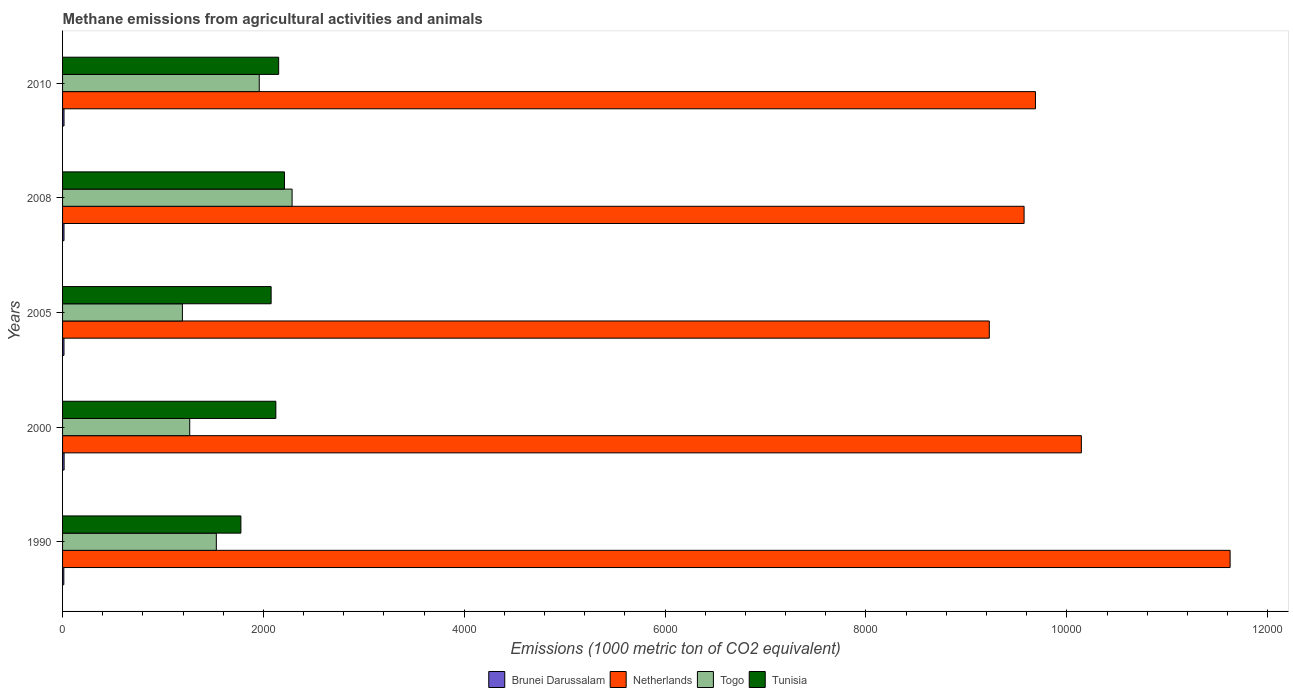Are the number of bars per tick equal to the number of legend labels?
Provide a succinct answer. Yes. Are the number of bars on each tick of the Y-axis equal?
Make the answer very short. Yes. How many bars are there on the 4th tick from the bottom?
Your answer should be compact. 4. In how many cases, is the number of bars for a given year not equal to the number of legend labels?
Provide a short and direct response. 0. Across all years, what is the maximum amount of methane emitted in Brunei Darussalam?
Offer a very short reply. 15.3. Across all years, what is the minimum amount of methane emitted in Tunisia?
Offer a terse response. 1775.7. In which year was the amount of methane emitted in Netherlands maximum?
Make the answer very short. 1990. What is the total amount of methane emitted in Togo in the graph?
Give a very brief answer. 8234.7. What is the difference between the amount of methane emitted in Tunisia in 2000 and that in 2010?
Give a very brief answer. -28.1. What is the difference between the amount of methane emitted in Brunei Darussalam in 1990 and the amount of methane emitted in Netherlands in 2000?
Provide a succinct answer. -1.01e+04. What is the average amount of methane emitted in Tunisia per year?
Make the answer very short. 2067.6. In the year 2000, what is the difference between the amount of methane emitted in Togo and amount of methane emitted in Brunei Darussalam?
Offer a very short reply. 1250.9. What is the ratio of the amount of methane emitted in Netherlands in 1990 to that in 2008?
Offer a very short reply. 1.21. Is the amount of methane emitted in Brunei Darussalam in 1990 less than that in 2005?
Provide a short and direct response. Yes. Is the difference between the amount of methane emitted in Togo in 1990 and 2010 greater than the difference between the amount of methane emitted in Brunei Darussalam in 1990 and 2010?
Give a very brief answer. No. What is the difference between the highest and the second highest amount of methane emitted in Netherlands?
Keep it short and to the point. 1481.2. What is the difference between the highest and the lowest amount of methane emitted in Brunei Darussalam?
Make the answer very short. 2.8. Is the sum of the amount of methane emitted in Netherlands in 2000 and 2008 greater than the maximum amount of methane emitted in Brunei Darussalam across all years?
Your response must be concise. Yes. What does the 4th bar from the top in 1990 represents?
Your response must be concise. Brunei Darussalam. What does the 1st bar from the bottom in 2005 represents?
Make the answer very short. Brunei Darussalam. How many bars are there?
Your response must be concise. 20. Are all the bars in the graph horizontal?
Offer a very short reply. Yes. How many years are there in the graph?
Your answer should be very brief. 5. What is the difference between two consecutive major ticks on the X-axis?
Your response must be concise. 2000. Are the values on the major ticks of X-axis written in scientific E-notation?
Offer a terse response. No. How many legend labels are there?
Provide a short and direct response. 4. What is the title of the graph?
Ensure brevity in your answer.  Methane emissions from agricultural activities and animals. Does "Hong Kong" appear as one of the legend labels in the graph?
Your response must be concise. No. What is the label or title of the X-axis?
Your answer should be compact. Emissions (1000 metric ton of CO2 equivalent). What is the label or title of the Y-axis?
Your answer should be very brief. Years. What is the Emissions (1000 metric ton of CO2 equivalent) of Netherlands in 1990?
Offer a very short reply. 1.16e+04. What is the Emissions (1000 metric ton of CO2 equivalent) in Togo in 1990?
Keep it short and to the point. 1531.1. What is the Emissions (1000 metric ton of CO2 equivalent) of Tunisia in 1990?
Provide a succinct answer. 1775.7. What is the Emissions (1000 metric ton of CO2 equivalent) in Netherlands in 2000?
Your answer should be compact. 1.01e+04. What is the Emissions (1000 metric ton of CO2 equivalent) of Togo in 2000?
Keep it short and to the point. 1266.2. What is the Emissions (1000 metric ton of CO2 equivalent) in Tunisia in 2000?
Give a very brief answer. 2123.8. What is the Emissions (1000 metric ton of CO2 equivalent) of Brunei Darussalam in 2005?
Your answer should be very brief. 14.1. What is the Emissions (1000 metric ton of CO2 equivalent) of Netherlands in 2005?
Ensure brevity in your answer.  9228. What is the Emissions (1000 metric ton of CO2 equivalent) of Togo in 2005?
Ensure brevity in your answer.  1193.3. What is the Emissions (1000 metric ton of CO2 equivalent) of Tunisia in 2005?
Offer a very short reply. 2076.8. What is the Emissions (1000 metric ton of CO2 equivalent) of Netherlands in 2008?
Provide a succinct answer. 9574.5. What is the Emissions (1000 metric ton of CO2 equivalent) in Togo in 2008?
Keep it short and to the point. 2285.6. What is the Emissions (1000 metric ton of CO2 equivalent) of Tunisia in 2008?
Your answer should be compact. 2209.8. What is the Emissions (1000 metric ton of CO2 equivalent) of Netherlands in 2010?
Offer a very short reply. 9687.8. What is the Emissions (1000 metric ton of CO2 equivalent) in Togo in 2010?
Offer a terse response. 1958.5. What is the Emissions (1000 metric ton of CO2 equivalent) of Tunisia in 2010?
Offer a terse response. 2151.9. Across all years, what is the maximum Emissions (1000 metric ton of CO2 equivalent) in Brunei Darussalam?
Your response must be concise. 15.3. Across all years, what is the maximum Emissions (1000 metric ton of CO2 equivalent) in Netherlands?
Your answer should be very brief. 1.16e+04. Across all years, what is the maximum Emissions (1000 metric ton of CO2 equivalent) of Togo?
Offer a very short reply. 2285.6. Across all years, what is the maximum Emissions (1000 metric ton of CO2 equivalent) of Tunisia?
Provide a short and direct response. 2209.8. Across all years, what is the minimum Emissions (1000 metric ton of CO2 equivalent) of Netherlands?
Provide a short and direct response. 9228. Across all years, what is the minimum Emissions (1000 metric ton of CO2 equivalent) of Togo?
Provide a succinct answer. 1193.3. Across all years, what is the minimum Emissions (1000 metric ton of CO2 equivalent) of Tunisia?
Provide a succinct answer. 1775.7. What is the total Emissions (1000 metric ton of CO2 equivalent) in Brunei Darussalam in the graph?
Make the answer very short. 70.6. What is the total Emissions (1000 metric ton of CO2 equivalent) of Netherlands in the graph?
Your answer should be very brief. 5.03e+04. What is the total Emissions (1000 metric ton of CO2 equivalent) in Togo in the graph?
Offer a very short reply. 8234.7. What is the total Emissions (1000 metric ton of CO2 equivalent) of Tunisia in the graph?
Offer a terse response. 1.03e+04. What is the difference between the Emissions (1000 metric ton of CO2 equivalent) of Brunei Darussalam in 1990 and that in 2000?
Your response must be concise. -2.8. What is the difference between the Emissions (1000 metric ton of CO2 equivalent) in Netherlands in 1990 and that in 2000?
Your answer should be compact. 1481.2. What is the difference between the Emissions (1000 metric ton of CO2 equivalent) of Togo in 1990 and that in 2000?
Give a very brief answer. 264.9. What is the difference between the Emissions (1000 metric ton of CO2 equivalent) in Tunisia in 1990 and that in 2000?
Ensure brevity in your answer.  -348.1. What is the difference between the Emissions (1000 metric ton of CO2 equivalent) of Brunei Darussalam in 1990 and that in 2005?
Provide a short and direct response. -1.6. What is the difference between the Emissions (1000 metric ton of CO2 equivalent) of Netherlands in 1990 and that in 2005?
Your answer should be compact. 2398. What is the difference between the Emissions (1000 metric ton of CO2 equivalent) of Togo in 1990 and that in 2005?
Keep it short and to the point. 337.8. What is the difference between the Emissions (1000 metric ton of CO2 equivalent) of Tunisia in 1990 and that in 2005?
Provide a short and direct response. -301.1. What is the difference between the Emissions (1000 metric ton of CO2 equivalent) in Netherlands in 1990 and that in 2008?
Make the answer very short. 2051.5. What is the difference between the Emissions (1000 metric ton of CO2 equivalent) of Togo in 1990 and that in 2008?
Give a very brief answer. -754.5. What is the difference between the Emissions (1000 metric ton of CO2 equivalent) of Tunisia in 1990 and that in 2008?
Your response must be concise. -434.1. What is the difference between the Emissions (1000 metric ton of CO2 equivalent) of Netherlands in 1990 and that in 2010?
Your answer should be very brief. 1938.2. What is the difference between the Emissions (1000 metric ton of CO2 equivalent) in Togo in 1990 and that in 2010?
Your answer should be very brief. -427.4. What is the difference between the Emissions (1000 metric ton of CO2 equivalent) in Tunisia in 1990 and that in 2010?
Make the answer very short. -376.2. What is the difference between the Emissions (1000 metric ton of CO2 equivalent) in Brunei Darussalam in 2000 and that in 2005?
Your response must be concise. 1.2. What is the difference between the Emissions (1000 metric ton of CO2 equivalent) of Netherlands in 2000 and that in 2005?
Provide a succinct answer. 916.8. What is the difference between the Emissions (1000 metric ton of CO2 equivalent) in Togo in 2000 and that in 2005?
Offer a terse response. 72.9. What is the difference between the Emissions (1000 metric ton of CO2 equivalent) in Netherlands in 2000 and that in 2008?
Provide a succinct answer. 570.3. What is the difference between the Emissions (1000 metric ton of CO2 equivalent) of Togo in 2000 and that in 2008?
Give a very brief answer. -1019.4. What is the difference between the Emissions (1000 metric ton of CO2 equivalent) of Tunisia in 2000 and that in 2008?
Provide a short and direct response. -86. What is the difference between the Emissions (1000 metric ton of CO2 equivalent) in Netherlands in 2000 and that in 2010?
Give a very brief answer. 457. What is the difference between the Emissions (1000 metric ton of CO2 equivalent) of Togo in 2000 and that in 2010?
Your response must be concise. -692.3. What is the difference between the Emissions (1000 metric ton of CO2 equivalent) in Tunisia in 2000 and that in 2010?
Provide a short and direct response. -28.1. What is the difference between the Emissions (1000 metric ton of CO2 equivalent) in Brunei Darussalam in 2005 and that in 2008?
Your response must be concise. -0.2. What is the difference between the Emissions (1000 metric ton of CO2 equivalent) of Netherlands in 2005 and that in 2008?
Your answer should be compact. -346.5. What is the difference between the Emissions (1000 metric ton of CO2 equivalent) in Togo in 2005 and that in 2008?
Your answer should be very brief. -1092.3. What is the difference between the Emissions (1000 metric ton of CO2 equivalent) of Tunisia in 2005 and that in 2008?
Provide a short and direct response. -133. What is the difference between the Emissions (1000 metric ton of CO2 equivalent) in Netherlands in 2005 and that in 2010?
Your response must be concise. -459.8. What is the difference between the Emissions (1000 metric ton of CO2 equivalent) in Togo in 2005 and that in 2010?
Offer a very short reply. -765.2. What is the difference between the Emissions (1000 metric ton of CO2 equivalent) of Tunisia in 2005 and that in 2010?
Your answer should be compact. -75.1. What is the difference between the Emissions (1000 metric ton of CO2 equivalent) in Brunei Darussalam in 2008 and that in 2010?
Your answer should be very brief. -0.1. What is the difference between the Emissions (1000 metric ton of CO2 equivalent) of Netherlands in 2008 and that in 2010?
Ensure brevity in your answer.  -113.3. What is the difference between the Emissions (1000 metric ton of CO2 equivalent) of Togo in 2008 and that in 2010?
Ensure brevity in your answer.  327.1. What is the difference between the Emissions (1000 metric ton of CO2 equivalent) in Tunisia in 2008 and that in 2010?
Make the answer very short. 57.9. What is the difference between the Emissions (1000 metric ton of CO2 equivalent) of Brunei Darussalam in 1990 and the Emissions (1000 metric ton of CO2 equivalent) of Netherlands in 2000?
Your answer should be very brief. -1.01e+04. What is the difference between the Emissions (1000 metric ton of CO2 equivalent) in Brunei Darussalam in 1990 and the Emissions (1000 metric ton of CO2 equivalent) in Togo in 2000?
Offer a terse response. -1253.7. What is the difference between the Emissions (1000 metric ton of CO2 equivalent) in Brunei Darussalam in 1990 and the Emissions (1000 metric ton of CO2 equivalent) in Tunisia in 2000?
Offer a very short reply. -2111.3. What is the difference between the Emissions (1000 metric ton of CO2 equivalent) of Netherlands in 1990 and the Emissions (1000 metric ton of CO2 equivalent) of Togo in 2000?
Ensure brevity in your answer.  1.04e+04. What is the difference between the Emissions (1000 metric ton of CO2 equivalent) in Netherlands in 1990 and the Emissions (1000 metric ton of CO2 equivalent) in Tunisia in 2000?
Give a very brief answer. 9502.2. What is the difference between the Emissions (1000 metric ton of CO2 equivalent) in Togo in 1990 and the Emissions (1000 metric ton of CO2 equivalent) in Tunisia in 2000?
Offer a very short reply. -592.7. What is the difference between the Emissions (1000 metric ton of CO2 equivalent) in Brunei Darussalam in 1990 and the Emissions (1000 metric ton of CO2 equivalent) in Netherlands in 2005?
Ensure brevity in your answer.  -9215.5. What is the difference between the Emissions (1000 metric ton of CO2 equivalent) in Brunei Darussalam in 1990 and the Emissions (1000 metric ton of CO2 equivalent) in Togo in 2005?
Your response must be concise. -1180.8. What is the difference between the Emissions (1000 metric ton of CO2 equivalent) in Brunei Darussalam in 1990 and the Emissions (1000 metric ton of CO2 equivalent) in Tunisia in 2005?
Your response must be concise. -2064.3. What is the difference between the Emissions (1000 metric ton of CO2 equivalent) of Netherlands in 1990 and the Emissions (1000 metric ton of CO2 equivalent) of Togo in 2005?
Your answer should be very brief. 1.04e+04. What is the difference between the Emissions (1000 metric ton of CO2 equivalent) of Netherlands in 1990 and the Emissions (1000 metric ton of CO2 equivalent) of Tunisia in 2005?
Make the answer very short. 9549.2. What is the difference between the Emissions (1000 metric ton of CO2 equivalent) of Togo in 1990 and the Emissions (1000 metric ton of CO2 equivalent) of Tunisia in 2005?
Give a very brief answer. -545.7. What is the difference between the Emissions (1000 metric ton of CO2 equivalent) of Brunei Darussalam in 1990 and the Emissions (1000 metric ton of CO2 equivalent) of Netherlands in 2008?
Make the answer very short. -9562. What is the difference between the Emissions (1000 metric ton of CO2 equivalent) in Brunei Darussalam in 1990 and the Emissions (1000 metric ton of CO2 equivalent) in Togo in 2008?
Your response must be concise. -2273.1. What is the difference between the Emissions (1000 metric ton of CO2 equivalent) in Brunei Darussalam in 1990 and the Emissions (1000 metric ton of CO2 equivalent) in Tunisia in 2008?
Your response must be concise. -2197.3. What is the difference between the Emissions (1000 metric ton of CO2 equivalent) of Netherlands in 1990 and the Emissions (1000 metric ton of CO2 equivalent) of Togo in 2008?
Your answer should be very brief. 9340.4. What is the difference between the Emissions (1000 metric ton of CO2 equivalent) in Netherlands in 1990 and the Emissions (1000 metric ton of CO2 equivalent) in Tunisia in 2008?
Keep it short and to the point. 9416.2. What is the difference between the Emissions (1000 metric ton of CO2 equivalent) in Togo in 1990 and the Emissions (1000 metric ton of CO2 equivalent) in Tunisia in 2008?
Ensure brevity in your answer.  -678.7. What is the difference between the Emissions (1000 metric ton of CO2 equivalent) of Brunei Darussalam in 1990 and the Emissions (1000 metric ton of CO2 equivalent) of Netherlands in 2010?
Provide a succinct answer. -9675.3. What is the difference between the Emissions (1000 metric ton of CO2 equivalent) in Brunei Darussalam in 1990 and the Emissions (1000 metric ton of CO2 equivalent) in Togo in 2010?
Provide a succinct answer. -1946. What is the difference between the Emissions (1000 metric ton of CO2 equivalent) in Brunei Darussalam in 1990 and the Emissions (1000 metric ton of CO2 equivalent) in Tunisia in 2010?
Make the answer very short. -2139.4. What is the difference between the Emissions (1000 metric ton of CO2 equivalent) of Netherlands in 1990 and the Emissions (1000 metric ton of CO2 equivalent) of Togo in 2010?
Offer a very short reply. 9667.5. What is the difference between the Emissions (1000 metric ton of CO2 equivalent) in Netherlands in 1990 and the Emissions (1000 metric ton of CO2 equivalent) in Tunisia in 2010?
Your answer should be compact. 9474.1. What is the difference between the Emissions (1000 metric ton of CO2 equivalent) of Togo in 1990 and the Emissions (1000 metric ton of CO2 equivalent) of Tunisia in 2010?
Offer a very short reply. -620.8. What is the difference between the Emissions (1000 metric ton of CO2 equivalent) of Brunei Darussalam in 2000 and the Emissions (1000 metric ton of CO2 equivalent) of Netherlands in 2005?
Ensure brevity in your answer.  -9212.7. What is the difference between the Emissions (1000 metric ton of CO2 equivalent) of Brunei Darussalam in 2000 and the Emissions (1000 metric ton of CO2 equivalent) of Togo in 2005?
Your answer should be very brief. -1178. What is the difference between the Emissions (1000 metric ton of CO2 equivalent) of Brunei Darussalam in 2000 and the Emissions (1000 metric ton of CO2 equivalent) of Tunisia in 2005?
Your response must be concise. -2061.5. What is the difference between the Emissions (1000 metric ton of CO2 equivalent) of Netherlands in 2000 and the Emissions (1000 metric ton of CO2 equivalent) of Togo in 2005?
Provide a succinct answer. 8951.5. What is the difference between the Emissions (1000 metric ton of CO2 equivalent) of Netherlands in 2000 and the Emissions (1000 metric ton of CO2 equivalent) of Tunisia in 2005?
Keep it short and to the point. 8068. What is the difference between the Emissions (1000 metric ton of CO2 equivalent) in Togo in 2000 and the Emissions (1000 metric ton of CO2 equivalent) in Tunisia in 2005?
Offer a terse response. -810.6. What is the difference between the Emissions (1000 metric ton of CO2 equivalent) in Brunei Darussalam in 2000 and the Emissions (1000 metric ton of CO2 equivalent) in Netherlands in 2008?
Provide a succinct answer. -9559.2. What is the difference between the Emissions (1000 metric ton of CO2 equivalent) in Brunei Darussalam in 2000 and the Emissions (1000 metric ton of CO2 equivalent) in Togo in 2008?
Your answer should be compact. -2270.3. What is the difference between the Emissions (1000 metric ton of CO2 equivalent) of Brunei Darussalam in 2000 and the Emissions (1000 metric ton of CO2 equivalent) of Tunisia in 2008?
Offer a terse response. -2194.5. What is the difference between the Emissions (1000 metric ton of CO2 equivalent) of Netherlands in 2000 and the Emissions (1000 metric ton of CO2 equivalent) of Togo in 2008?
Offer a very short reply. 7859.2. What is the difference between the Emissions (1000 metric ton of CO2 equivalent) in Netherlands in 2000 and the Emissions (1000 metric ton of CO2 equivalent) in Tunisia in 2008?
Provide a succinct answer. 7935. What is the difference between the Emissions (1000 metric ton of CO2 equivalent) in Togo in 2000 and the Emissions (1000 metric ton of CO2 equivalent) in Tunisia in 2008?
Give a very brief answer. -943.6. What is the difference between the Emissions (1000 metric ton of CO2 equivalent) of Brunei Darussalam in 2000 and the Emissions (1000 metric ton of CO2 equivalent) of Netherlands in 2010?
Give a very brief answer. -9672.5. What is the difference between the Emissions (1000 metric ton of CO2 equivalent) in Brunei Darussalam in 2000 and the Emissions (1000 metric ton of CO2 equivalent) in Togo in 2010?
Give a very brief answer. -1943.2. What is the difference between the Emissions (1000 metric ton of CO2 equivalent) in Brunei Darussalam in 2000 and the Emissions (1000 metric ton of CO2 equivalent) in Tunisia in 2010?
Provide a short and direct response. -2136.6. What is the difference between the Emissions (1000 metric ton of CO2 equivalent) in Netherlands in 2000 and the Emissions (1000 metric ton of CO2 equivalent) in Togo in 2010?
Provide a succinct answer. 8186.3. What is the difference between the Emissions (1000 metric ton of CO2 equivalent) of Netherlands in 2000 and the Emissions (1000 metric ton of CO2 equivalent) of Tunisia in 2010?
Offer a very short reply. 7992.9. What is the difference between the Emissions (1000 metric ton of CO2 equivalent) of Togo in 2000 and the Emissions (1000 metric ton of CO2 equivalent) of Tunisia in 2010?
Offer a very short reply. -885.7. What is the difference between the Emissions (1000 metric ton of CO2 equivalent) in Brunei Darussalam in 2005 and the Emissions (1000 metric ton of CO2 equivalent) in Netherlands in 2008?
Your answer should be compact. -9560.4. What is the difference between the Emissions (1000 metric ton of CO2 equivalent) of Brunei Darussalam in 2005 and the Emissions (1000 metric ton of CO2 equivalent) of Togo in 2008?
Offer a very short reply. -2271.5. What is the difference between the Emissions (1000 metric ton of CO2 equivalent) in Brunei Darussalam in 2005 and the Emissions (1000 metric ton of CO2 equivalent) in Tunisia in 2008?
Make the answer very short. -2195.7. What is the difference between the Emissions (1000 metric ton of CO2 equivalent) in Netherlands in 2005 and the Emissions (1000 metric ton of CO2 equivalent) in Togo in 2008?
Your response must be concise. 6942.4. What is the difference between the Emissions (1000 metric ton of CO2 equivalent) in Netherlands in 2005 and the Emissions (1000 metric ton of CO2 equivalent) in Tunisia in 2008?
Ensure brevity in your answer.  7018.2. What is the difference between the Emissions (1000 metric ton of CO2 equivalent) of Togo in 2005 and the Emissions (1000 metric ton of CO2 equivalent) of Tunisia in 2008?
Offer a very short reply. -1016.5. What is the difference between the Emissions (1000 metric ton of CO2 equivalent) of Brunei Darussalam in 2005 and the Emissions (1000 metric ton of CO2 equivalent) of Netherlands in 2010?
Offer a terse response. -9673.7. What is the difference between the Emissions (1000 metric ton of CO2 equivalent) in Brunei Darussalam in 2005 and the Emissions (1000 metric ton of CO2 equivalent) in Togo in 2010?
Offer a very short reply. -1944.4. What is the difference between the Emissions (1000 metric ton of CO2 equivalent) of Brunei Darussalam in 2005 and the Emissions (1000 metric ton of CO2 equivalent) of Tunisia in 2010?
Your answer should be very brief. -2137.8. What is the difference between the Emissions (1000 metric ton of CO2 equivalent) of Netherlands in 2005 and the Emissions (1000 metric ton of CO2 equivalent) of Togo in 2010?
Provide a short and direct response. 7269.5. What is the difference between the Emissions (1000 metric ton of CO2 equivalent) of Netherlands in 2005 and the Emissions (1000 metric ton of CO2 equivalent) of Tunisia in 2010?
Your answer should be very brief. 7076.1. What is the difference between the Emissions (1000 metric ton of CO2 equivalent) of Togo in 2005 and the Emissions (1000 metric ton of CO2 equivalent) of Tunisia in 2010?
Offer a terse response. -958.6. What is the difference between the Emissions (1000 metric ton of CO2 equivalent) of Brunei Darussalam in 2008 and the Emissions (1000 metric ton of CO2 equivalent) of Netherlands in 2010?
Make the answer very short. -9673.5. What is the difference between the Emissions (1000 metric ton of CO2 equivalent) of Brunei Darussalam in 2008 and the Emissions (1000 metric ton of CO2 equivalent) of Togo in 2010?
Offer a terse response. -1944.2. What is the difference between the Emissions (1000 metric ton of CO2 equivalent) in Brunei Darussalam in 2008 and the Emissions (1000 metric ton of CO2 equivalent) in Tunisia in 2010?
Make the answer very short. -2137.6. What is the difference between the Emissions (1000 metric ton of CO2 equivalent) in Netherlands in 2008 and the Emissions (1000 metric ton of CO2 equivalent) in Togo in 2010?
Ensure brevity in your answer.  7616. What is the difference between the Emissions (1000 metric ton of CO2 equivalent) in Netherlands in 2008 and the Emissions (1000 metric ton of CO2 equivalent) in Tunisia in 2010?
Keep it short and to the point. 7422.6. What is the difference between the Emissions (1000 metric ton of CO2 equivalent) of Togo in 2008 and the Emissions (1000 metric ton of CO2 equivalent) of Tunisia in 2010?
Provide a succinct answer. 133.7. What is the average Emissions (1000 metric ton of CO2 equivalent) in Brunei Darussalam per year?
Offer a very short reply. 14.12. What is the average Emissions (1000 metric ton of CO2 equivalent) in Netherlands per year?
Your response must be concise. 1.01e+04. What is the average Emissions (1000 metric ton of CO2 equivalent) of Togo per year?
Offer a very short reply. 1646.94. What is the average Emissions (1000 metric ton of CO2 equivalent) in Tunisia per year?
Ensure brevity in your answer.  2067.6. In the year 1990, what is the difference between the Emissions (1000 metric ton of CO2 equivalent) in Brunei Darussalam and Emissions (1000 metric ton of CO2 equivalent) in Netherlands?
Make the answer very short. -1.16e+04. In the year 1990, what is the difference between the Emissions (1000 metric ton of CO2 equivalent) of Brunei Darussalam and Emissions (1000 metric ton of CO2 equivalent) of Togo?
Give a very brief answer. -1518.6. In the year 1990, what is the difference between the Emissions (1000 metric ton of CO2 equivalent) of Brunei Darussalam and Emissions (1000 metric ton of CO2 equivalent) of Tunisia?
Your answer should be compact. -1763.2. In the year 1990, what is the difference between the Emissions (1000 metric ton of CO2 equivalent) in Netherlands and Emissions (1000 metric ton of CO2 equivalent) in Togo?
Ensure brevity in your answer.  1.01e+04. In the year 1990, what is the difference between the Emissions (1000 metric ton of CO2 equivalent) in Netherlands and Emissions (1000 metric ton of CO2 equivalent) in Tunisia?
Offer a very short reply. 9850.3. In the year 1990, what is the difference between the Emissions (1000 metric ton of CO2 equivalent) in Togo and Emissions (1000 metric ton of CO2 equivalent) in Tunisia?
Give a very brief answer. -244.6. In the year 2000, what is the difference between the Emissions (1000 metric ton of CO2 equivalent) in Brunei Darussalam and Emissions (1000 metric ton of CO2 equivalent) in Netherlands?
Offer a terse response. -1.01e+04. In the year 2000, what is the difference between the Emissions (1000 metric ton of CO2 equivalent) of Brunei Darussalam and Emissions (1000 metric ton of CO2 equivalent) of Togo?
Your response must be concise. -1250.9. In the year 2000, what is the difference between the Emissions (1000 metric ton of CO2 equivalent) of Brunei Darussalam and Emissions (1000 metric ton of CO2 equivalent) of Tunisia?
Provide a short and direct response. -2108.5. In the year 2000, what is the difference between the Emissions (1000 metric ton of CO2 equivalent) of Netherlands and Emissions (1000 metric ton of CO2 equivalent) of Togo?
Make the answer very short. 8878.6. In the year 2000, what is the difference between the Emissions (1000 metric ton of CO2 equivalent) in Netherlands and Emissions (1000 metric ton of CO2 equivalent) in Tunisia?
Keep it short and to the point. 8021. In the year 2000, what is the difference between the Emissions (1000 metric ton of CO2 equivalent) in Togo and Emissions (1000 metric ton of CO2 equivalent) in Tunisia?
Your response must be concise. -857.6. In the year 2005, what is the difference between the Emissions (1000 metric ton of CO2 equivalent) in Brunei Darussalam and Emissions (1000 metric ton of CO2 equivalent) in Netherlands?
Your response must be concise. -9213.9. In the year 2005, what is the difference between the Emissions (1000 metric ton of CO2 equivalent) in Brunei Darussalam and Emissions (1000 metric ton of CO2 equivalent) in Togo?
Offer a terse response. -1179.2. In the year 2005, what is the difference between the Emissions (1000 metric ton of CO2 equivalent) of Brunei Darussalam and Emissions (1000 metric ton of CO2 equivalent) of Tunisia?
Provide a short and direct response. -2062.7. In the year 2005, what is the difference between the Emissions (1000 metric ton of CO2 equivalent) of Netherlands and Emissions (1000 metric ton of CO2 equivalent) of Togo?
Give a very brief answer. 8034.7. In the year 2005, what is the difference between the Emissions (1000 metric ton of CO2 equivalent) in Netherlands and Emissions (1000 metric ton of CO2 equivalent) in Tunisia?
Offer a very short reply. 7151.2. In the year 2005, what is the difference between the Emissions (1000 metric ton of CO2 equivalent) in Togo and Emissions (1000 metric ton of CO2 equivalent) in Tunisia?
Your response must be concise. -883.5. In the year 2008, what is the difference between the Emissions (1000 metric ton of CO2 equivalent) in Brunei Darussalam and Emissions (1000 metric ton of CO2 equivalent) in Netherlands?
Provide a succinct answer. -9560.2. In the year 2008, what is the difference between the Emissions (1000 metric ton of CO2 equivalent) of Brunei Darussalam and Emissions (1000 metric ton of CO2 equivalent) of Togo?
Your response must be concise. -2271.3. In the year 2008, what is the difference between the Emissions (1000 metric ton of CO2 equivalent) in Brunei Darussalam and Emissions (1000 metric ton of CO2 equivalent) in Tunisia?
Your response must be concise. -2195.5. In the year 2008, what is the difference between the Emissions (1000 metric ton of CO2 equivalent) of Netherlands and Emissions (1000 metric ton of CO2 equivalent) of Togo?
Give a very brief answer. 7288.9. In the year 2008, what is the difference between the Emissions (1000 metric ton of CO2 equivalent) in Netherlands and Emissions (1000 metric ton of CO2 equivalent) in Tunisia?
Provide a short and direct response. 7364.7. In the year 2008, what is the difference between the Emissions (1000 metric ton of CO2 equivalent) in Togo and Emissions (1000 metric ton of CO2 equivalent) in Tunisia?
Your answer should be very brief. 75.8. In the year 2010, what is the difference between the Emissions (1000 metric ton of CO2 equivalent) in Brunei Darussalam and Emissions (1000 metric ton of CO2 equivalent) in Netherlands?
Provide a short and direct response. -9673.4. In the year 2010, what is the difference between the Emissions (1000 metric ton of CO2 equivalent) of Brunei Darussalam and Emissions (1000 metric ton of CO2 equivalent) of Togo?
Make the answer very short. -1944.1. In the year 2010, what is the difference between the Emissions (1000 metric ton of CO2 equivalent) of Brunei Darussalam and Emissions (1000 metric ton of CO2 equivalent) of Tunisia?
Offer a very short reply. -2137.5. In the year 2010, what is the difference between the Emissions (1000 metric ton of CO2 equivalent) in Netherlands and Emissions (1000 metric ton of CO2 equivalent) in Togo?
Your response must be concise. 7729.3. In the year 2010, what is the difference between the Emissions (1000 metric ton of CO2 equivalent) in Netherlands and Emissions (1000 metric ton of CO2 equivalent) in Tunisia?
Your response must be concise. 7535.9. In the year 2010, what is the difference between the Emissions (1000 metric ton of CO2 equivalent) in Togo and Emissions (1000 metric ton of CO2 equivalent) in Tunisia?
Provide a succinct answer. -193.4. What is the ratio of the Emissions (1000 metric ton of CO2 equivalent) in Brunei Darussalam in 1990 to that in 2000?
Your answer should be compact. 0.82. What is the ratio of the Emissions (1000 metric ton of CO2 equivalent) in Netherlands in 1990 to that in 2000?
Your answer should be compact. 1.15. What is the ratio of the Emissions (1000 metric ton of CO2 equivalent) in Togo in 1990 to that in 2000?
Your answer should be compact. 1.21. What is the ratio of the Emissions (1000 metric ton of CO2 equivalent) of Tunisia in 1990 to that in 2000?
Give a very brief answer. 0.84. What is the ratio of the Emissions (1000 metric ton of CO2 equivalent) of Brunei Darussalam in 1990 to that in 2005?
Offer a very short reply. 0.89. What is the ratio of the Emissions (1000 metric ton of CO2 equivalent) in Netherlands in 1990 to that in 2005?
Give a very brief answer. 1.26. What is the ratio of the Emissions (1000 metric ton of CO2 equivalent) in Togo in 1990 to that in 2005?
Offer a very short reply. 1.28. What is the ratio of the Emissions (1000 metric ton of CO2 equivalent) in Tunisia in 1990 to that in 2005?
Ensure brevity in your answer.  0.85. What is the ratio of the Emissions (1000 metric ton of CO2 equivalent) in Brunei Darussalam in 1990 to that in 2008?
Your answer should be very brief. 0.87. What is the ratio of the Emissions (1000 metric ton of CO2 equivalent) of Netherlands in 1990 to that in 2008?
Keep it short and to the point. 1.21. What is the ratio of the Emissions (1000 metric ton of CO2 equivalent) in Togo in 1990 to that in 2008?
Give a very brief answer. 0.67. What is the ratio of the Emissions (1000 metric ton of CO2 equivalent) in Tunisia in 1990 to that in 2008?
Offer a very short reply. 0.8. What is the ratio of the Emissions (1000 metric ton of CO2 equivalent) of Brunei Darussalam in 1990 to that in 2010?
Offer a terse response. 0.87. What is the ratio of the Emissions (1000 metric ton of CO2 equivalent) of Netherlands in 1990 to that in 2010?
Your response must be concise. 1.2. What is the ratio of the Emissions (1000 metric ton of CO2 equivalent) of Togo in 1990 to that in 2010?
Ensure brevity in your answer.  0.78. What is the ratio of the Emissions (1000 metric ton of CO2 equivalent) in Tunisia in 1990 to that in 2010?
Your answer should be compact. 0.83. What is the ratio of the Emissions (1000 metric ton of CO2 equivalent) in Brunei Darussalam in 2000 to that in 2005?
Provide a short and direct response. 1.09. What is the ratio of the Emissions (1000 metric ton of CO2 equivalent) of Netherlands in 2000 to that in 2005?
Ensure brevity in your answer.  1.1. What is the ratio of the Emissions (1000 metric ton of CO2 equivalent) in Togo in 2000 to that in 2005?
Your response must be concise. 1.06. What is the ratio of the Emissions (1000 metric ton of CO2 equivalent) in Tunisia in 2000 to that in 2005?
Offer a very short reply. 1.02. What is the ratio of the Emissions (1000 metric ton of CO2 equivalent) in Brunei Darussalam in 2000 to that in 2008?
Make the answer very short. 1.07. What is the ratio of the Emissions (1000 metric ton of CO2 equivalent) of Netherlands in 2000 to that in 2008?
Offer a very short reply. 1.06. What is the ratio of the Emissions (1000 metric ton of CO2 equivalent) of Togo in 2000 to that in 2008?
Ensure brevity in your answer.  0.55. What is the ratio of the Emissions (1000 metric ton of CO2 equivalent) in Tunisia in 2000 to that in 2008?
Your response must be concise. 0.96. What is the ratio of the Emissions (1000 metric ton of CO2 equivalent) in Netherlands in 2000 to that in 2010?
Your response must be concise. 1.05. What is the ratio of the Emissions (1000 metric ton of CO2 equivalent) in Togo in 2000 to that in 2010?
Your answer should be very brief. 0.65. What is the ratio of the Emissions (1000 metric ton of CO2 equivalent) of Tunisia in 2000 to that in 2010?
Keep it short and to the point. 0.99. What is the ratio of the Emissions (1000 metric ton of CO2 equivalent) of Brunei Darussalam in 2005 to that in 2008?
Provide a short and direct response. 0.99. What is the ratio of the Emissions (1000 metric ton of CO2 equivalent) in Netherlands in 2005 to that in 2008?
Your response must be concise. 0.96. What is the ratio of the Emissions (1000 metric ton of CO2 equivalent) of Togo in 2005 to that in 2008?
Provide a short and direct response. 0.52. What is the ratio of the Emissions (1000 metric ton of CO2 equivalent) in Tunisia in 2005 to that in 2008?
Your response must be concise. 0.94. What is the ratio of the Emissions (1000 metric ton of CO2 equivalent) of Brunei Darussalam in 2005 to that in 2010?
Ensure brevity in your answer.  0.98. What is the ratio of the Emissions (1000 metric ton of CO2 equivalent) in Netherlands in 2005 to that in 2010?
Your response must be concise. 0.95. What is the ratio of the Emissions (1000 metric ton of CO2 equivalent) of Togo in 2005 to that in 2010?
Ensure brevity in your answer.  0.61. What is the ratio of the Emissions (1000 metric ton of CO2 equivalent) of Tunisia in 2005 to that in 2010?
Your response must be concise. 0.97. What is the ratio of the Emissions (1000 metric ton of CO2 equivalent) of Brunei Darussalam in 2008 to that in 2010?
Your response must be concise. 0.99. What is the ratio of the Emissions (1000 metric ton of CO2 equivalent) in Netherlands in 2008 to that in 2010?
Offer a very short reply. 0.99. What is the ratio of the Emissions (1000 metric ton of CO2 equivalent) in Togo in 2008 to that in 2010?
Give a very brief answer. 1.17. What is the ratio of the Emissions (1000 metric ton of CO2 equivalent) of Tunisia in 2008 to that in 2010?
Provide a short and direct response. 1.03. What is the difference between the highest and the second highest Emissions (1000 metric ton of CO2 equivalent) in Netherlands?
Ensure brevity in your answer.  1481.2. What is the difference between the highest and the second highest Emissions (1000 metric ton of CO2 equivalent) in Togo?
Ensure brevity in your answer.  327.1. What is the difference between the highest and the second highest Emissions (1000 metric ton of CO2 equivalent) in Tunisia?
Provide a succinct answer. 57.9. What is the difference between the highest and the lowest Emissions (1000 metric ton of CO2 equivalent) in Netherlands?
Provide a short and direct response. 2398. What is the difference between the highest and the lowest Emissions (1000 metric ton of CO2 equivalent) in Togo?
Your response must be concise. 1092.3. What is the difference between the highest and the lowest Emissions (1000 metric ton of CO2 equivalent) of Tunisia?
Give a very brief answer. 434.1. 